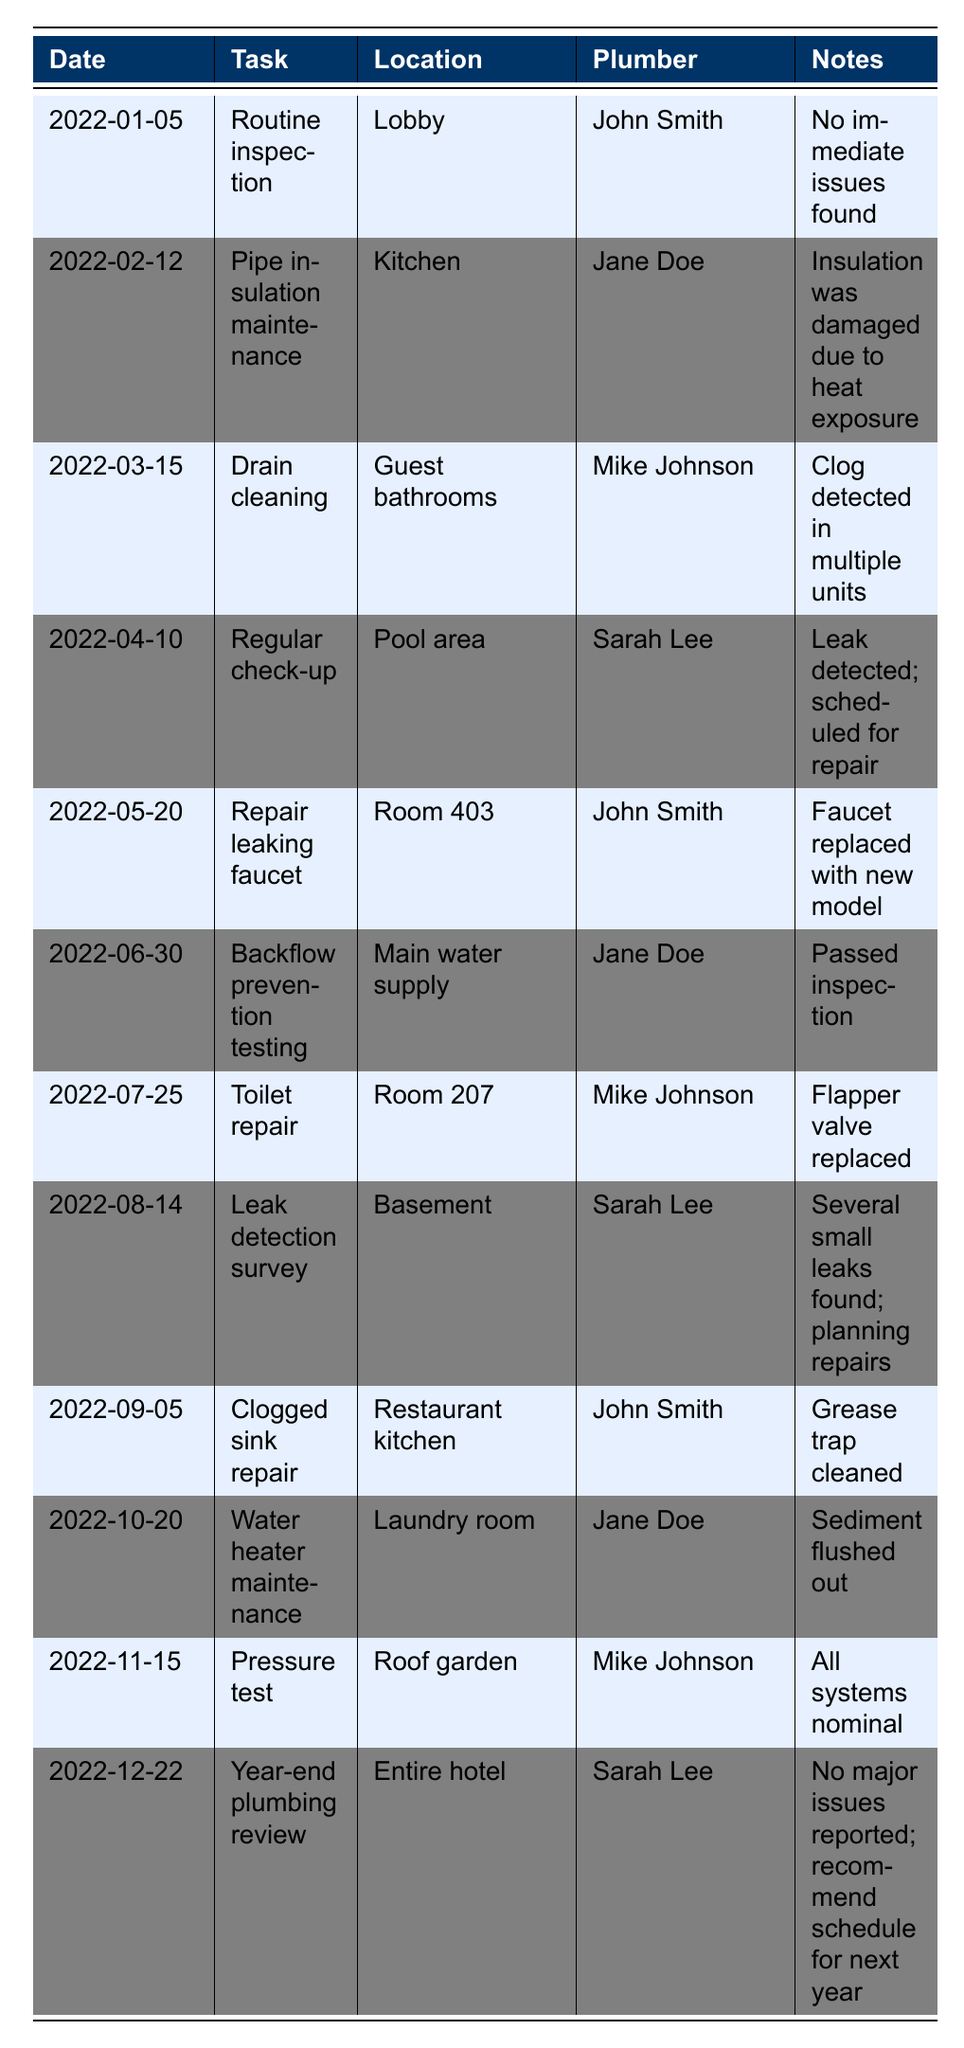What task was assigned to John Smith on January 5th? The table indicates that on January 5th, John Smith was assigned the task of "Routine inspection" in the Lobby.
Answer: Routine inspection How many plumbing repairs were conducted in guest rooms? From the table, the plumbing repairs in guest rooms are on May 20 (Room 403) and July 25 (Room 207). Therefore, 2 repairs were conducted in guest rooms.
Answer: 2 Which plumber performed the backflow prevention testing? Looking at the table, it shows that Jane Doe performed the backflow prevention testing on June 30.
Answer: Jane Doe Was there any repair after a leak was detected in the pool area? The table lists a leak detected in the pool area on April 10, but no specific repair is mentioned for that location subsequently, so the answer is no.
Answer: No What was the location of the leak detected during the leak detection survey? According to the table, the leak detection survey on August 14 found several small leaks in the Basement.
Answer: Basement Which task had the most recent date listed? The latest date in the table is December 22, which corresponds to the "Year-end plumbing review" for the entire hotel.
Answer: Year-end plumbing review Calculate the total number of plumbing maintenance tasks completed in 2022. The table lists 12 maintenance tasks, so by counting the number of entries, we find there are 12 tasks completed in total.
Answer: 12 How many tasks were related to inspections? The tasks related to inspections include the "Routine inspection" on January 5, "Backflow prevention testing" on June 30, and "Year-end plumbing review" on December 22, totaling 3 inspection-related tasks.
Answer: 3 Which month saw the highest number of maintenance tasks performed? Checking the table, each month has one task except for August, which lists a leak detection survey. Therefore, there is a tie, with one task each month.
Answer: No single month; all months have one task (except August has a survey) Did Mike Johnson work on any tasks in the pool area? The table notes that on April 10, there was a leak detected in the pool area assigned to Sarah Lee, meaning Mike Johnson did not work in that area.
Answer: No What was the outcome of the water heater maintenance task? The table shows that the water heater maintenance on October 20 involved "Sediment flushed out," which indicates the task was successfully completed.
Answer: Successful completion 